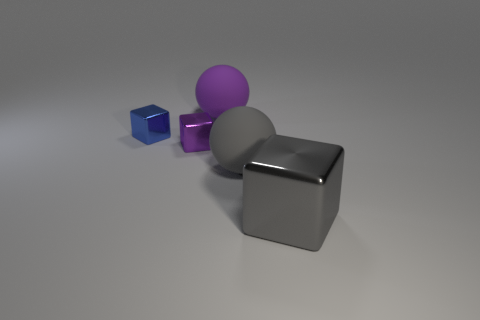Add 4 big brown spheres. How many objects exist? 9 Subtract all blocks. How many objects are left? 2 Add 5 big gray blocks. How many big gray blocks exist? 6 Subtract 0 yellow blocks. How many objects are left? 5 Subtract all tiny brown metallic blocks. Subtract all matte balls. How many objects are left? 3 Add 2 metallic objects. How many metallic objects are left? 5 